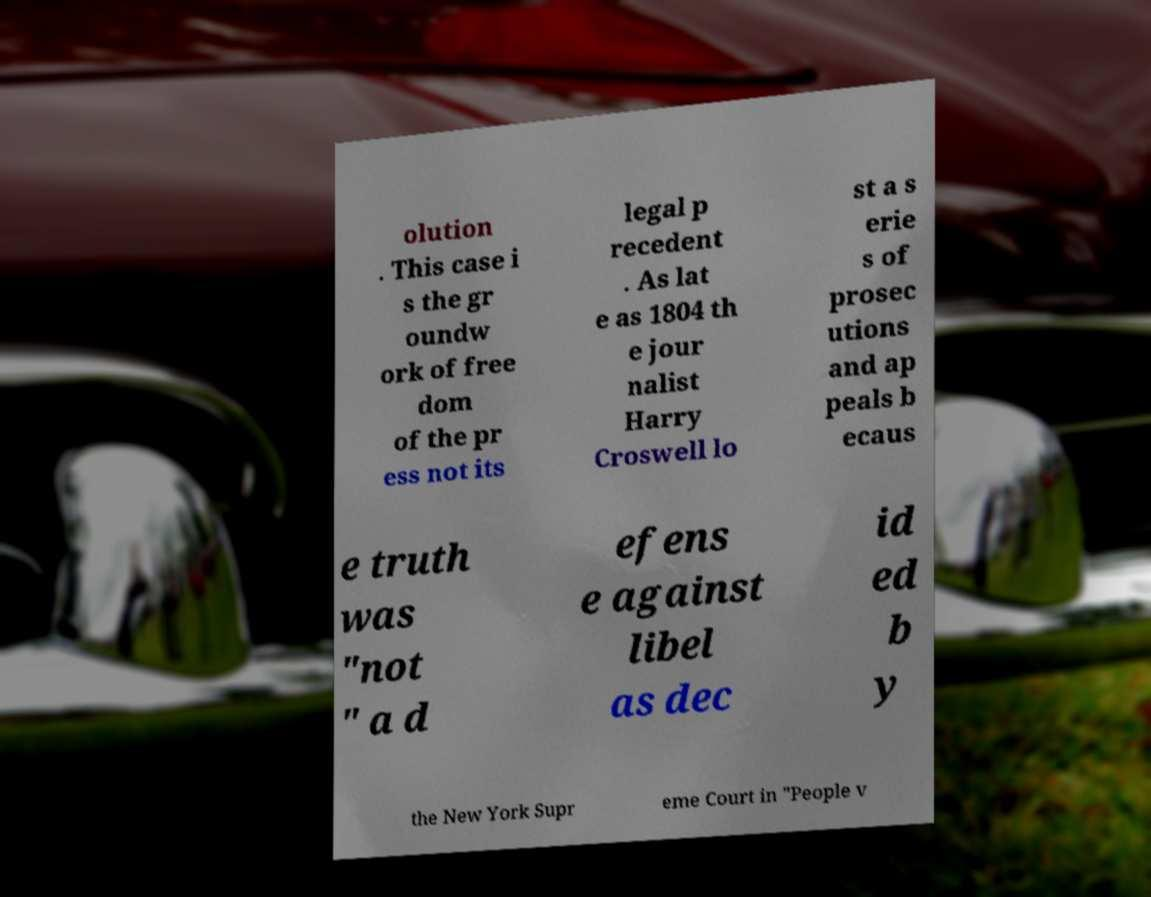Can you read and provide the text displayed in the image?This photo seems to have some interesting text. Can you extract and type it out for me? olution . This case i s the gr oundw ork of free dom of the pr ess not its legal p recedent . As lat e as 1804 th e jour nalist Harry Croswell lo st a s erie s of prosec utions and ap peals b ecaus e truth was "not " a d efens e against libel as dec id ed b y the New York Supr eme Court in "People v 